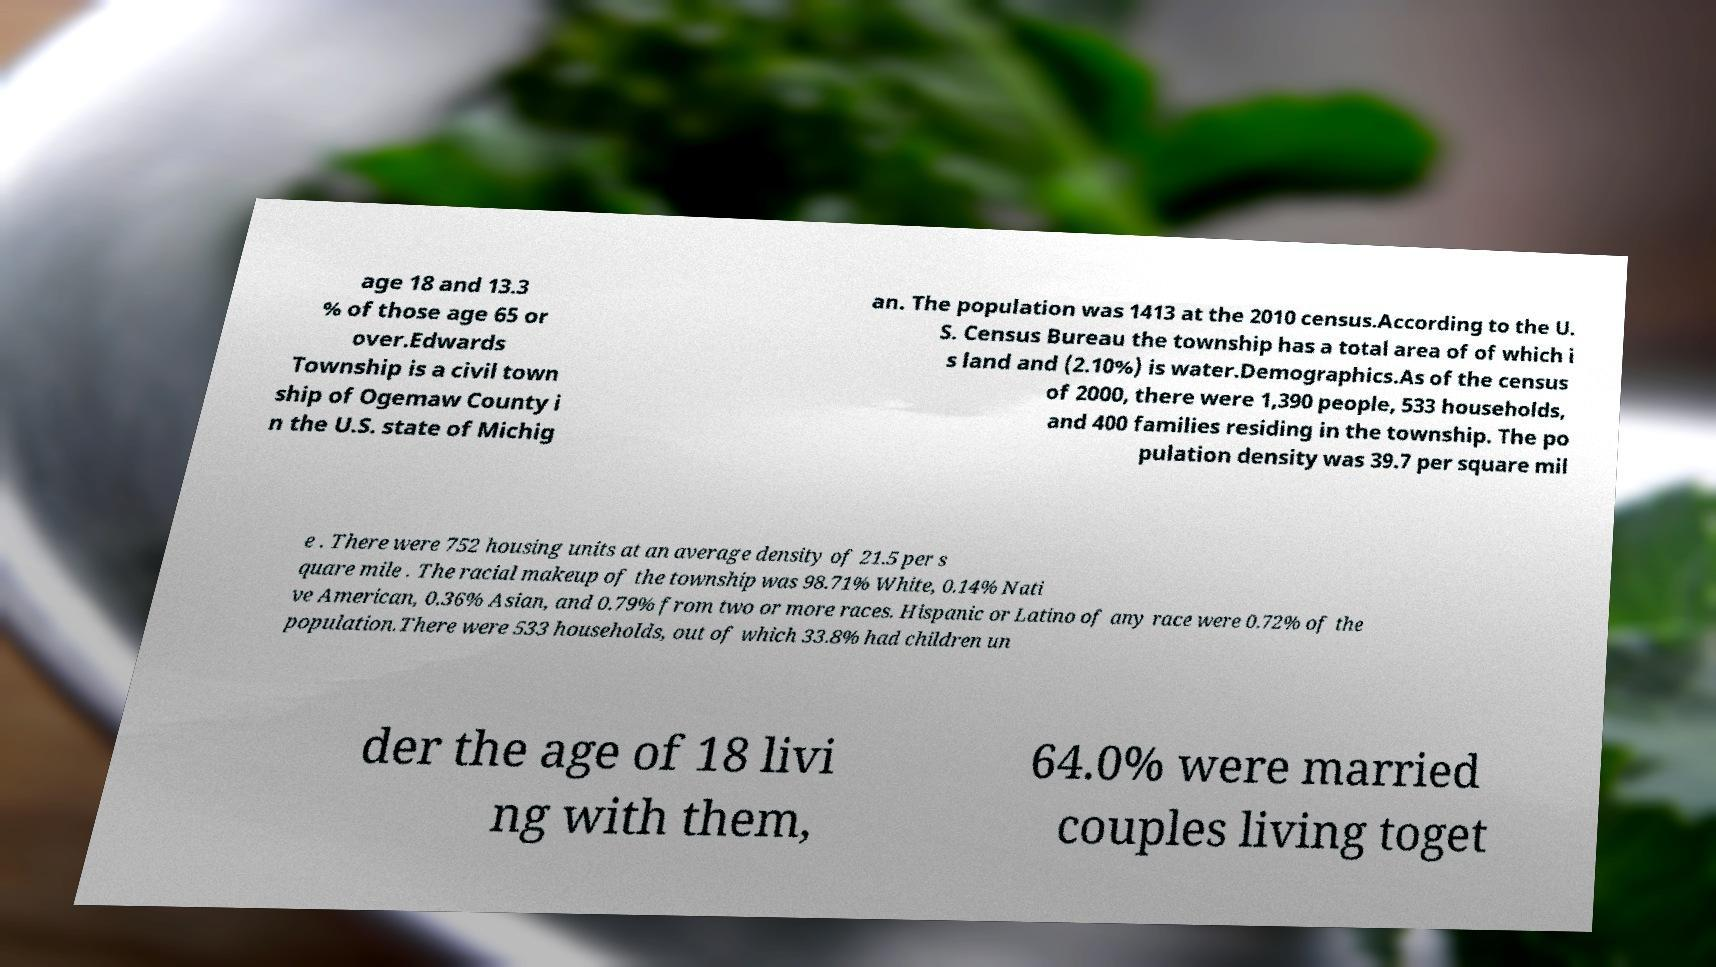Please identify and transcribe the text found in this image. age 18 and 13.3 % of those age 65 or over.Edwards Township is a civil town ship of Ogemaw County i n the U.S. state of Michig an. The population was 1413 at the 2010 census.According to the U. S. Census Bureau the township has a total area of of which i s land and (2.10%) is water.Demographics.As of the census of 2000, there were 1,390 people, 533 households, and 400 families residing in the township. The po pulation density was 39.7 per square mil e . There were 752 housing units at an average density of 21.5 per s quare mile . The racial makeup of the township was 98.71% White, 0.14% Nati ve American, 0.36% Asian, and 0.79% from two or more races. Hispanic or Latino of any race were 0.72% of the population.There were 533 households, out of which 33.8% had children un der the age of 18 livi ng with them, 64.0% were married couples living toget 